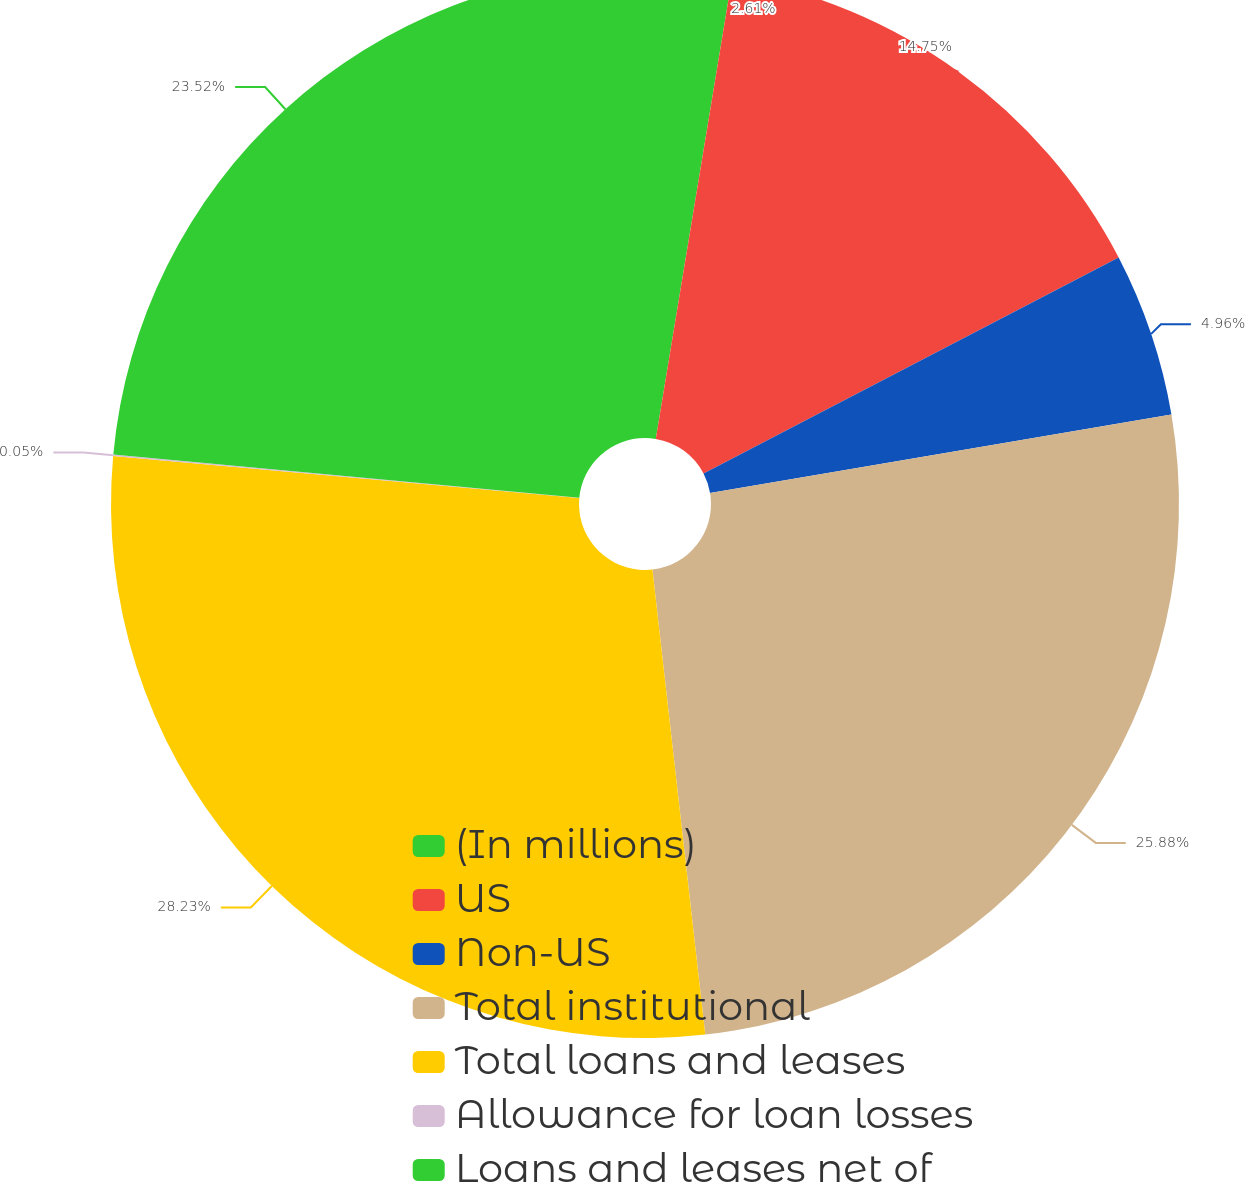Convert chart. <chart><loc_0><loc_0><loc_500><loc_500><pie_chart><fcel>(In millions)<fcel>US<fcel>Non-US<fcel>Total institutional<fcel>Total loans and leases<fcel>Allowance for loan losses<fcel>Loans and leases net of<nl><fcel>2.61%<fcel>14.75%<fcel>4.96%<fcel>25.88%<fcel>28.23%<fcel>0.05%<fcel>23.52%<nl></chart> 